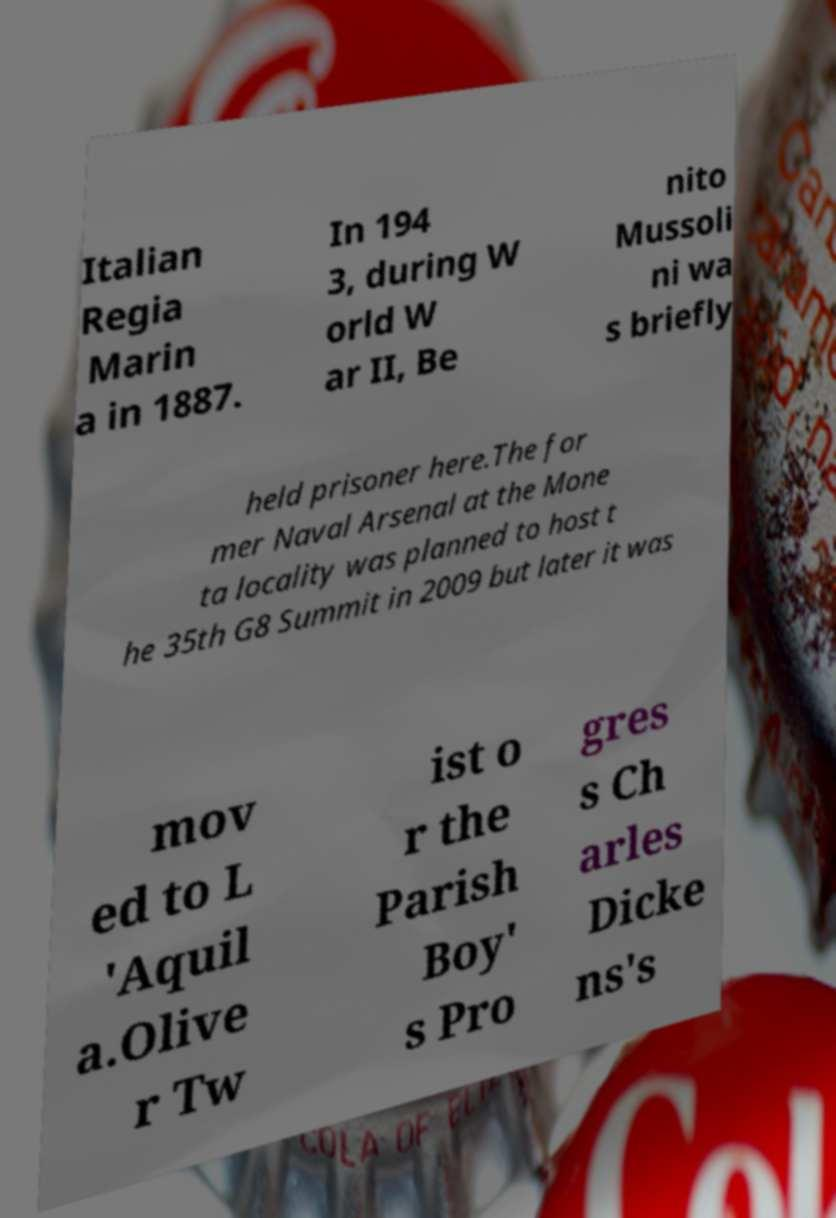Can you accurately transcribe the text from the provided image for me? Italian Regia Marin a in 1887. In 194 3, during W orld W ar II, Be nito Mussoli ni wa s briefly held prisoner here.The for mer Naval Arsenal at the Mone ta locality was planned to host t he 35th G8 Summit in 2009 but later it was mov ed to L 'Aquil a.Olive r Tw ist o r the Parish Boy' s Pro gres s Ch arles Dicke ns's 